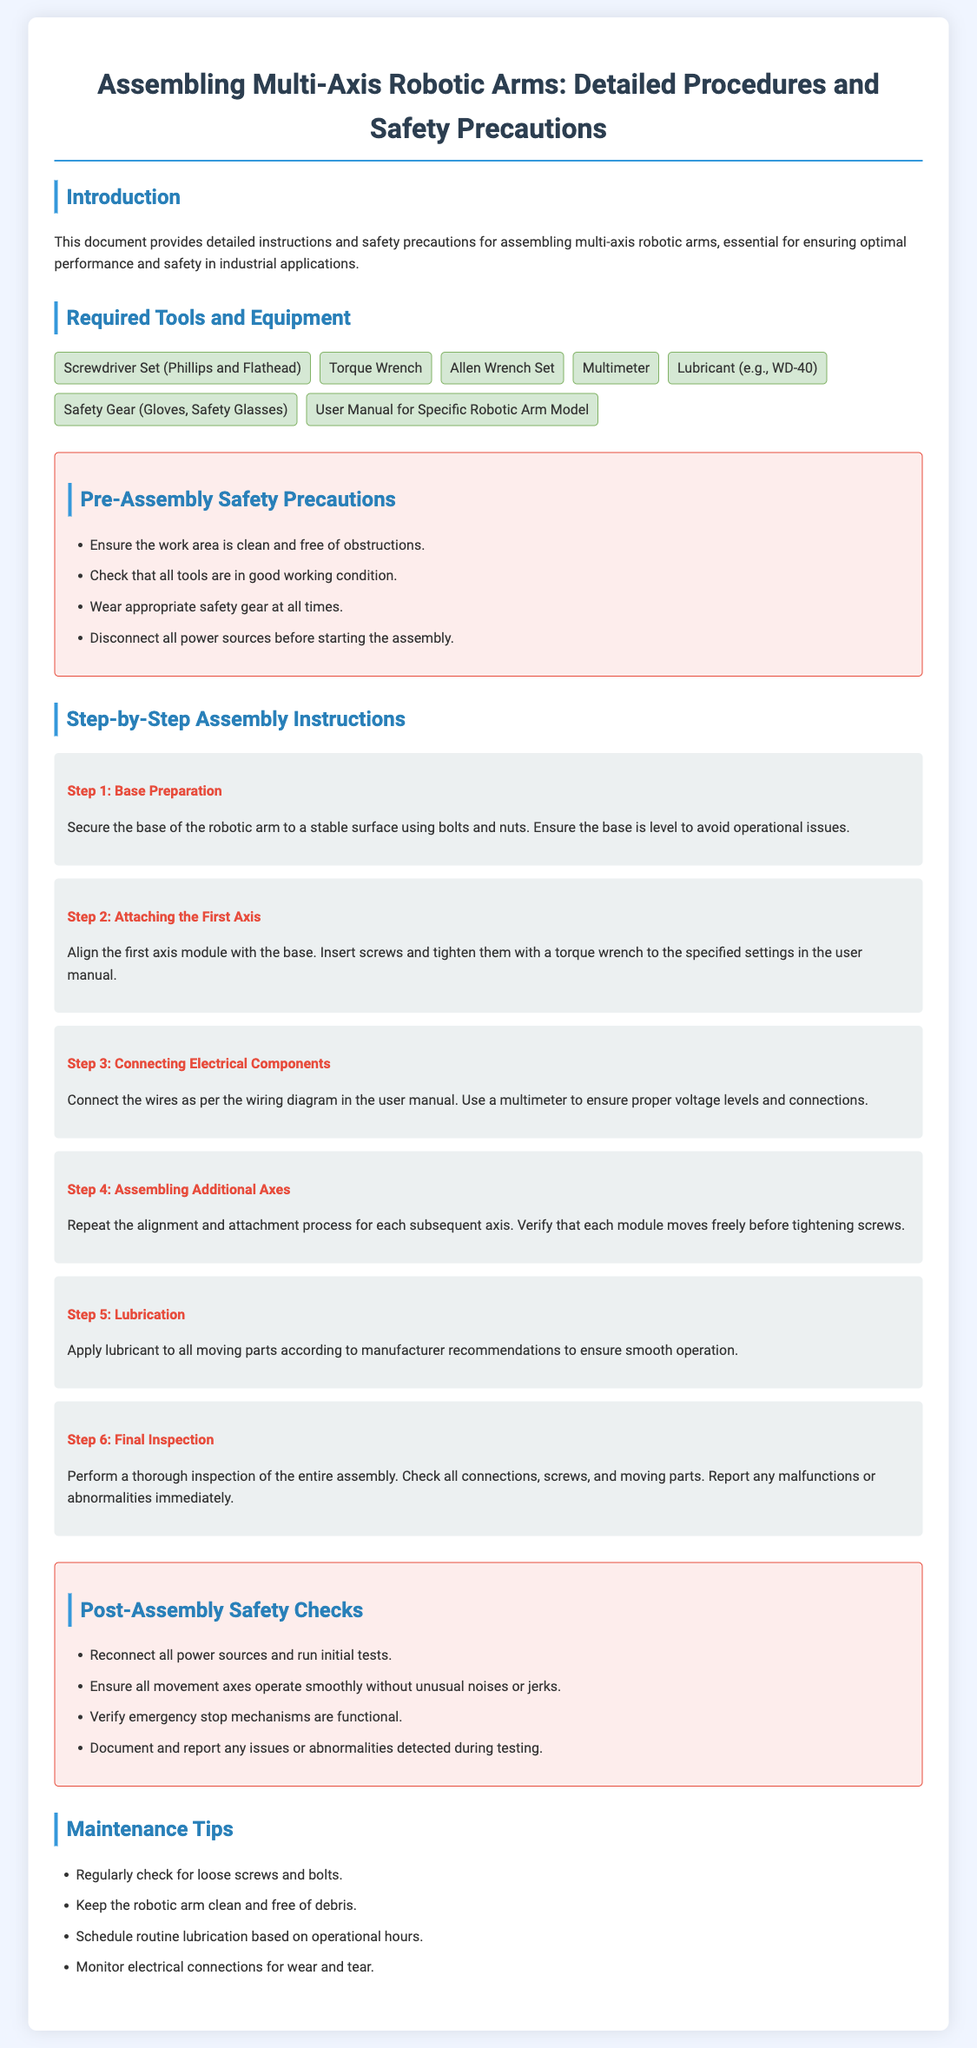What is the title of the document? The title of the document provides an overview of its content, which is "Assembling Multi-Axis Robotic Arms: Detailed Procedures and Safety Precautions."
Answer: Assembling Multi-Axis Robotic Arms: Detailed Procedures and Safety Precautions How many steps are listed in the assembly instructions? The document outlines a total of 6 steps for assembling the robotic arm.
Answer: 6 What is the first tool listed under Required Tools and Equipment? The first tool mentioned is a "Screwdriver Set (Phillips and Flathead)."
Answer: Screwdriver Set (Phillips and Flathead) What should be checked before starting the assembly? The document emphasizes checking that all tools are in good working condition before starting assembly.
Answer: Tools What is the purpose of applying lubricant? Lubricant is applied to all moving parts to ensure smooth operation as per the manufacturer's recommendations.
Answer: Smooth operation What should be done during the final inspection? During the final inspection, a thorough check should be performed on all connections, screws, and moving parts, with any malfunctions reported.
Answer: Report malfunctions 